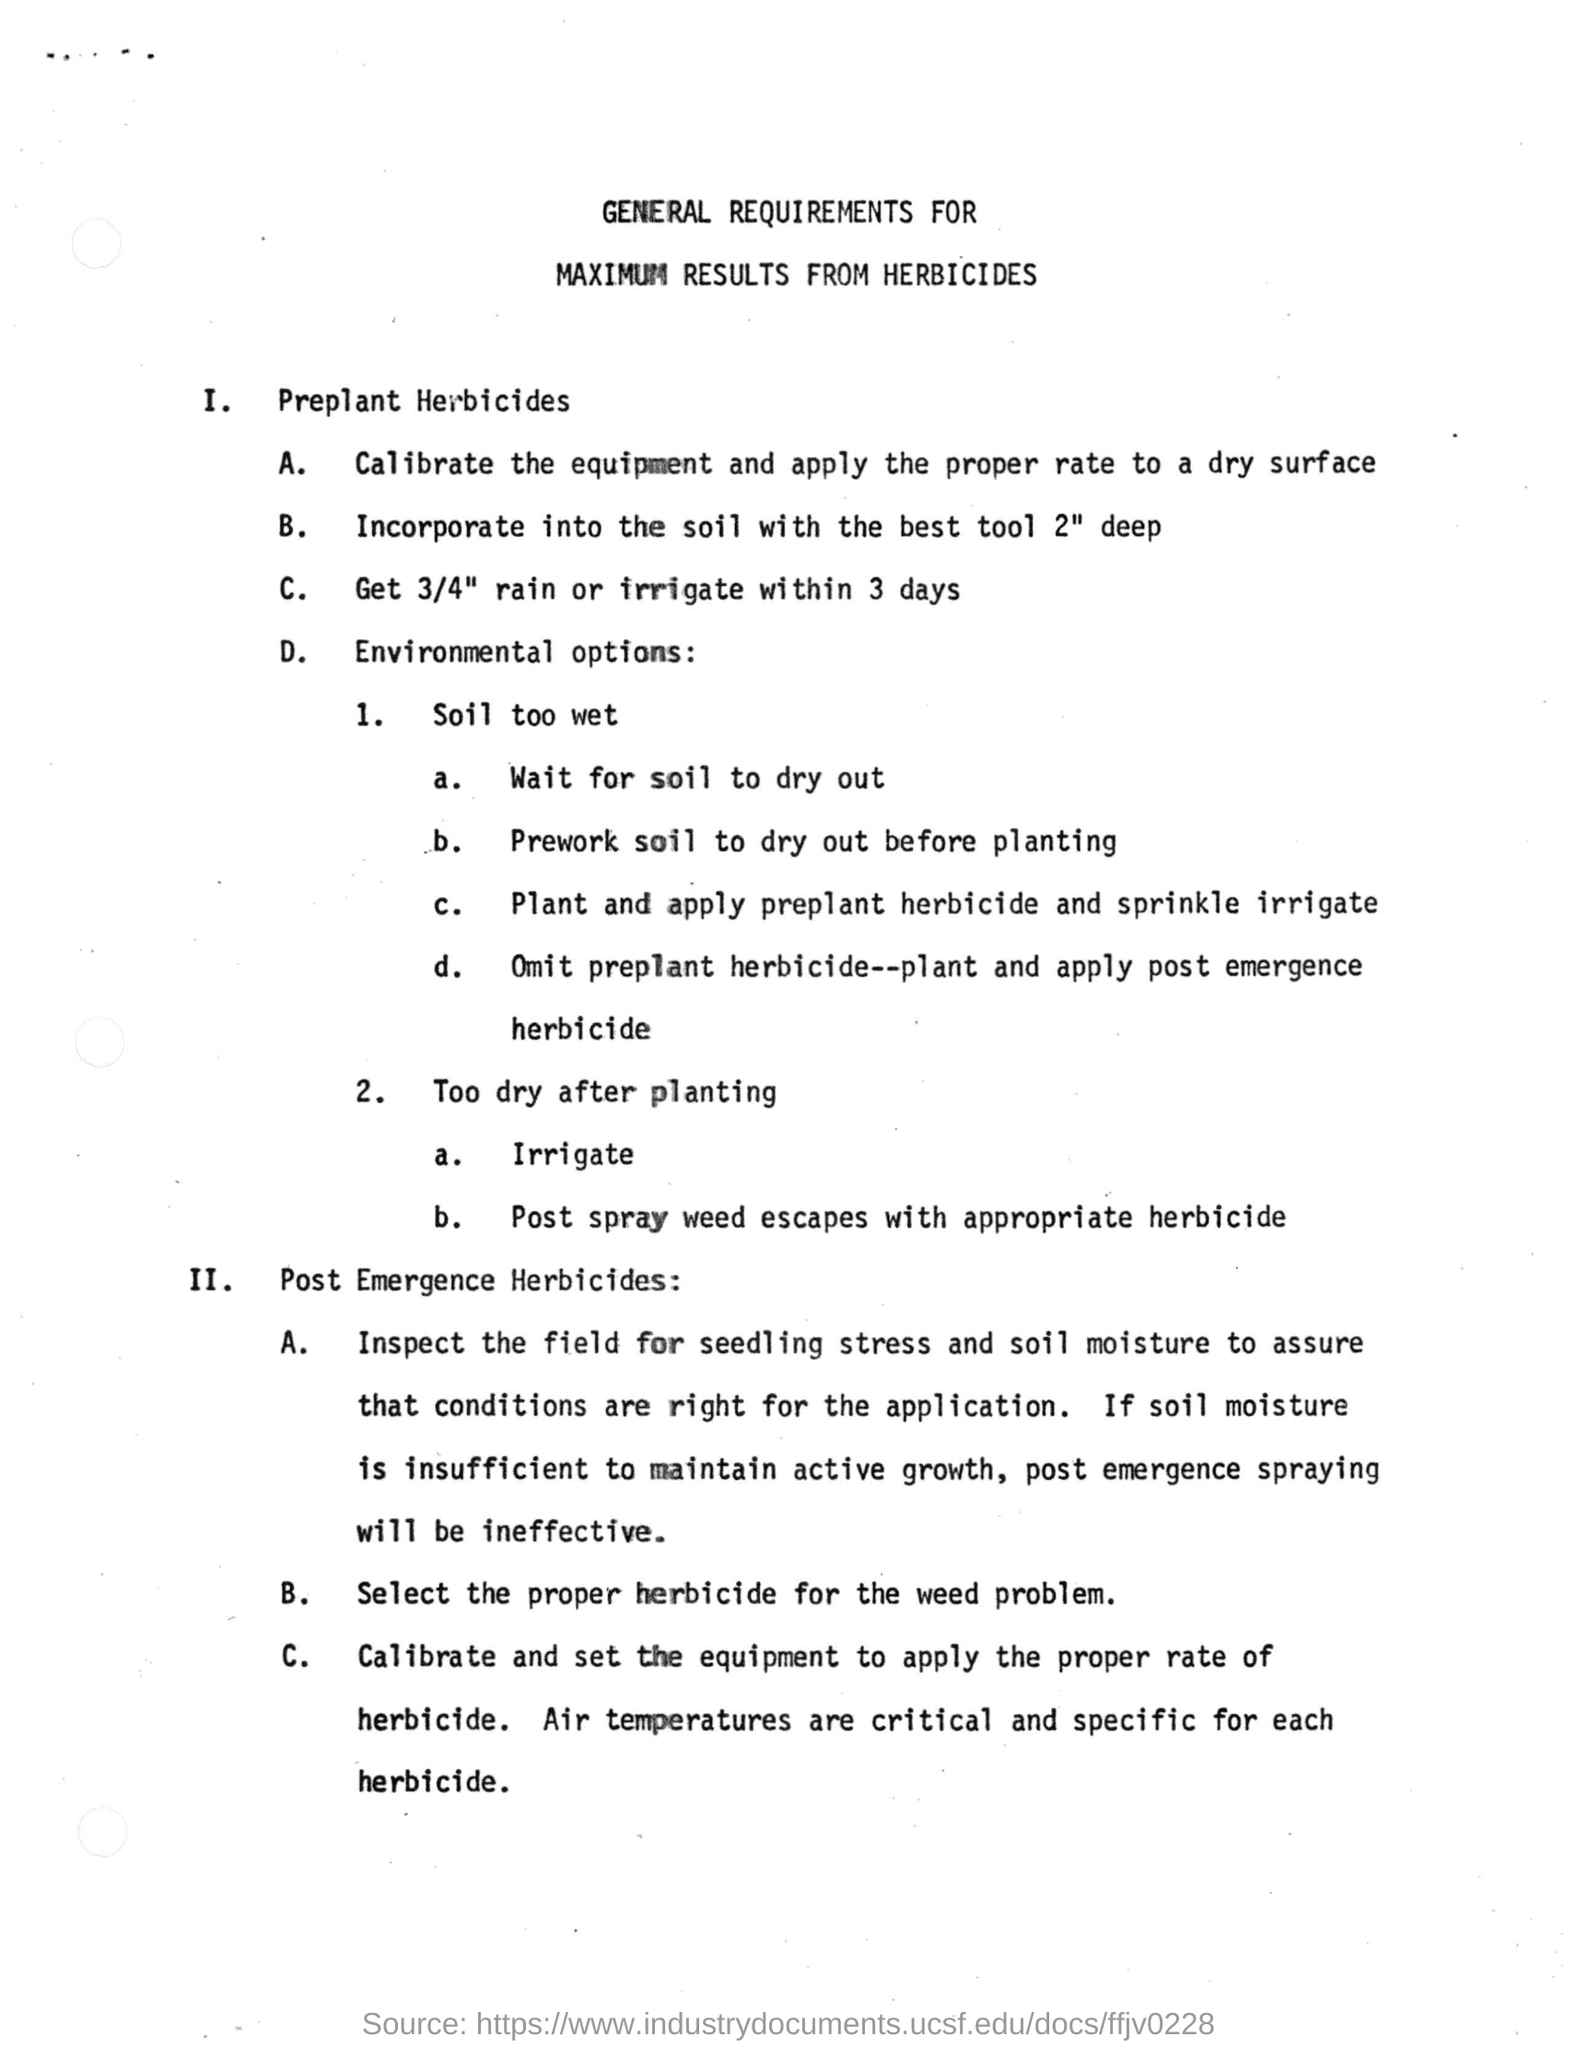How much deep we should incorporate the soil with the best tool?
Offer a terse response. 2" deep. How much rain should be received?
Provide a short and direct response. 3/4" rain. If soil is too wet what we should do first?
Provide a short and direct response. Wait for soil to dry out. 